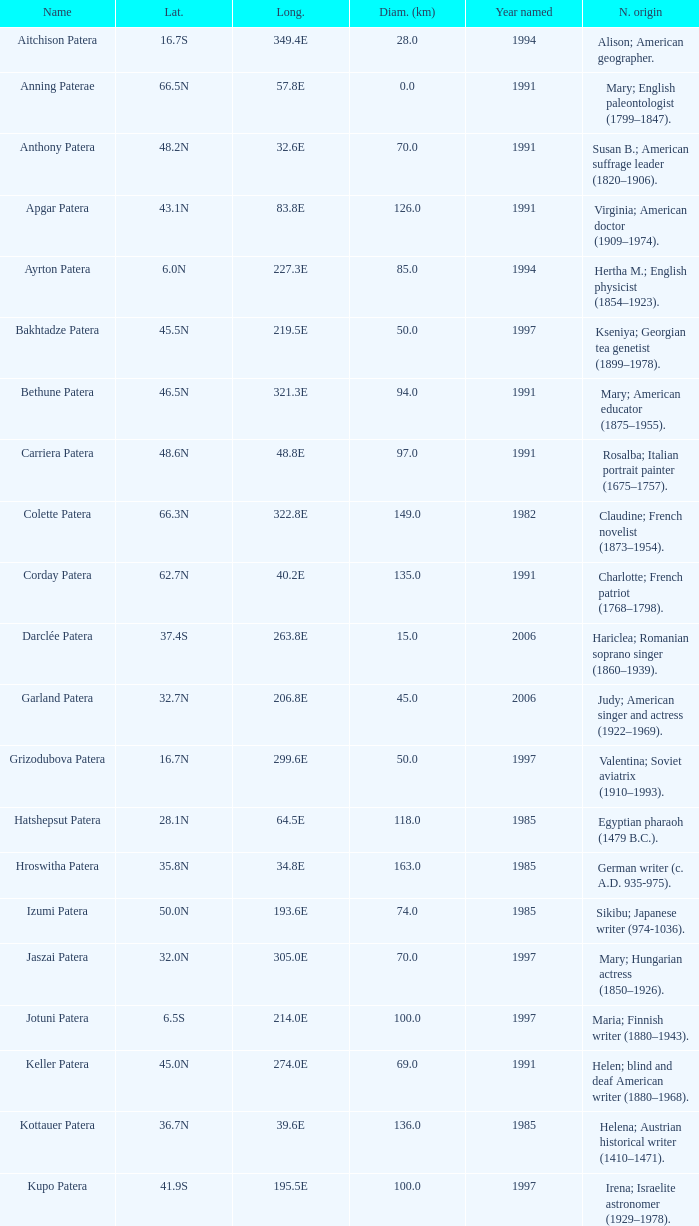Help me parse the entirety of this table. {'header': ['Name', 'Lat.', 'Long.', 'Diam. (km)', 'Year named', 'N. origin'], 'rows': [['Aitchison Patera', '16.7S', '349.4E', '28.0', '1994', 'Alison; American geographer.'], ['Anning Paterae', '66.5N', '57.8E', '0.0', '1991', 'Mary; English paleontologist (1799–1847).'], ['Anthony Patera', '48.2N', '32.6E', '70.0', '1991', 'Susan B.; American suffrage leader (1820–1906).'], ['Apgar Patera', '43.1N', '83.8E', '126.0', '1991', 'Virginia; American doctor (1909–1974).'], ['Ayrton Patera', '6.0N', '227.3E', '85.0', '1994', 'Hertha M.; English physicist (1854–1923).'], ['Bakhtadze Patera', '45.5N', '219.5E', '50.0', '1997', 'Kseniya; Georgian tea genetist (1899–1978).'], ['Bethune Patera', '46.5N', '321.3E', '94.0', '1991', 'Mary; American educator (1875–1955).'], ['Carriera Patera', '48.6N', '48.8E', '97.0', '1991', 'Rosalba; Italian portrait painter (1675–1757).'], ['Colette Patera', '66.3N', '322.8E', '149.0', '1982', 'Claudine; French novelist (1873–1954).'], ['Corday Patera', '62.7N', '40.2E', '135.0', '1991', 'Charlotte; French patriot (1768–1798).'], ['Darclée Patera', '37.4S', '263.8E', '15.0', '2006', 'Hariclea; Romanian soprano singer (1860–1939).'], ['Garland Patera', '32.7N', '206.8E', '45.0', '2006', 'Judy; American singer and actress (1922–1969).'], ['Grizodubova Patera', '16.7N', '299.6E', '50.0', '1997', 'Valentina; Soviet aviatrix (1910–1993).'], ['Hatshepsut Patera', '28.1N', '64.5E', '118.0', '1985', 'Egyptian pharaoh (1479 B.C.).'], ['Hroswitha Patera', '35.8N', '34.8E', '163.0', '1985', 'German writer (c. A.D. 935-975).'], ['Izumi Patera', '50.0N', '193.6E', '74.0', '1985', 'Sikibu; Japanese writer (974-1036).'], ['Jaszai Patera', '32.0N', '305.0E', '70.0', '1997', 'Mary; Hungarian actress (1850–1926).'], ['Jotuni Patera', '6.5S', '214.0E', '100.0', '1997', 'Maria; Finnish writer (1880–1943).'], ['Keller Patera', '45.0N', '274.0E', '69.0', '1991', 'Helen; blind and deaf American writer (1880–1968).'], ['Kottauer Patera', '36.7N', '39.6E', '136.0', '1985', 'Helena; Austrian historical writer (1410–1471).'], ['Kupo Patera', '41.9S', '195.5E', '100.0', '1997', 'Irena; Israelite astronomer (1929–1978).'], ['Ledoux Patera', '9.2S', '224.8E', '75.0', '1994', 'Jeanne; French artist (1767–1840).'], ['Lindgren Patera', '28.1N', '241.4E', '110.0', '2006', 'Astrid; Swedish author (1907–2002).'], ['Mehseti Patera', '16.0N', '311.0E', '60.0', '1997', 'Ganjevi; Azeri/Persian poet (c. 1050-c. 1100).'], ['Mezrina Patera', '33.3S', '68.8E', '60.0', '2000', 'Anna; Russian clay toy sculptor (1853–1938).'], ['Nordenflycht Patera', '35.0S', '266.0E', '140.0', '1997', 'Hedwig; Swedish poet (1718–1763).'], ['Panina Patera', '13.0S', '309.8E', '50.0', '1997', 'Varya; Gypsy/Russian singer (1872–1911).'], ['Payne-Gaposchkin Patera', '25.5S', '196.0E', '100.0', '1997', 'Cecilia Helena; American astronomer (1900–1979).'], ['Pocahontas Patera', '64.9N', '49.4E', '78.0', '1991', 'Powhatan Indian peacemaker (1595–1617).'], ['Raskova Paterae', '51.0S', '222.8E', '80.0', '1994', 'Marina M.; Russian aviator (1912–1943).'], ['Razia Patera', '46.2N', '197.8E', '157.0', '1985', 'Queen of Delhi Sultanate (India) (1236–1240).'], ['Shulzhenko Patera', '6.5N', '264.5E', '60.0', '1997', 'Klavdiya; Soviet singer (1906–1984).'], ['Siddons Patera', '61.6N', '340.6E', '47.0', '1997', 'Sarah; English actress (1755–1831).'], ['Stopes Patera', '42.6N', '46.5E', '169.0', '1991', 'Marie; English paleontologist (1880–1959).'], ['Tarbell Patera', '58.2S', '351.5E', '80.0', '1994', 'Ida; American author, editor (1857–1944).'], ['Teasdale Patera', '67.6S', '189.1E', '75.0', '1994', 'Sara; American poet (1884–1933).'], ['Tey Patera', '17.8S', '349.1E', '20.0', '1994', 'Josephine; Scottish author (1897–1952).'], ['Tipporah Patera', '38.9N', '43.0E', '99.0', '1985', 'Hebrew medical scholar (1500 B.C.).'], ['Vibert-Douglas Patera', '11.6S', '194.3E', '45.0', '2003', 'Allie; Canadian astronomer (1894–1988).'], ['Villepreux-Power Patera', '22.0S', '210.0E', '100.0', '1997', 'Jeannette; French marine biologist (1794–1871).'], ['Wilde Patera', '21.3S', '266.3E', '75.0', '2000', 'Lady Jane Francesca; Irish poet (1821–1891).'], ['Witte Patera', '25.8S', '247.65E', '35.0', '2006', 'Wilhelmine; German astronomer (1777–1854).'], ['Woodhull Patera', '37.4N', '305.4E', '83.0', '1991', 'Victoria; American-English lecturer (1838–1927).']]} What is the origin of the name of Keller Patera?  Helen; blind and deaf American writer (1880–1968). 